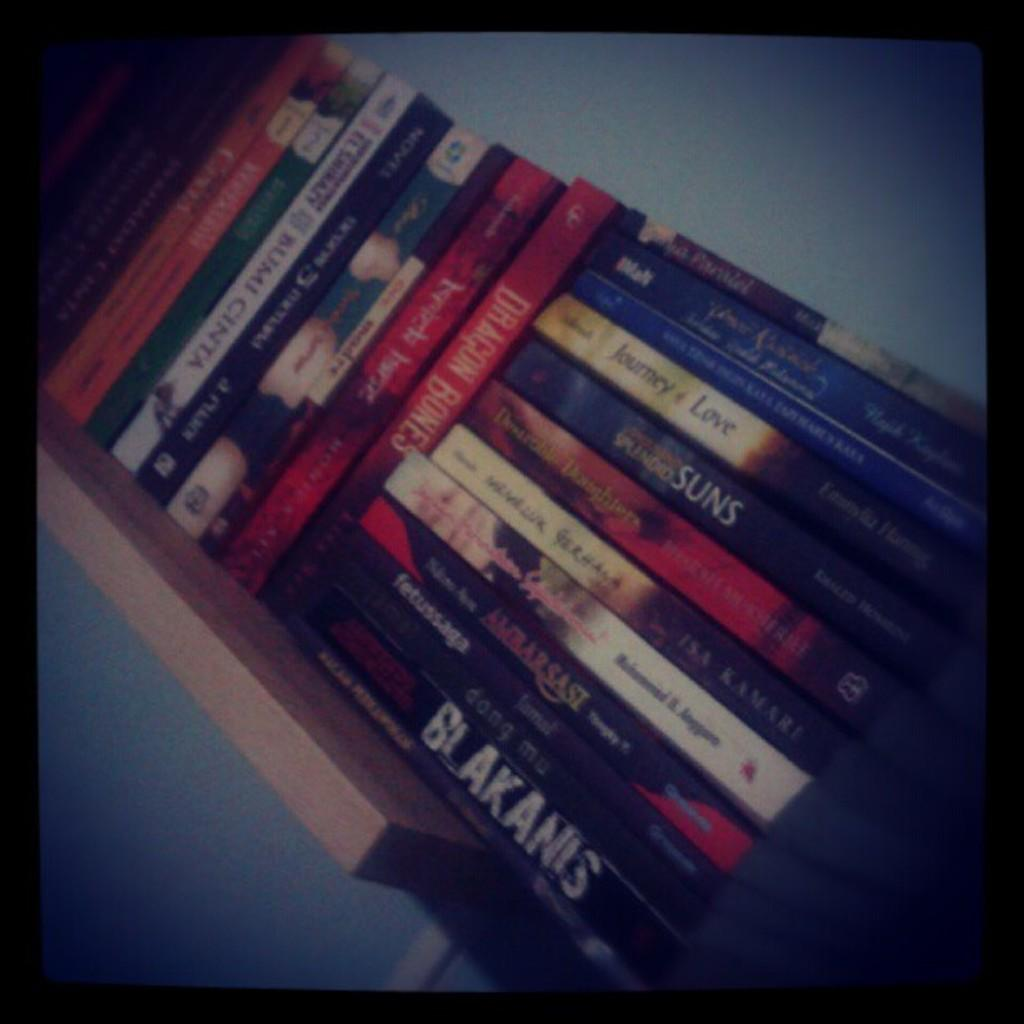<image>
Describe the image concisely. A bookshelf full of books including Journey of Love and Blakanis. 